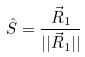<formula> <loc_0><loc_0><loc_500><loc_500>\hat { S } = \frac { \vec { R } _ { 1 } } { | | \vec { R } _ { 1 } | | }</formula> 